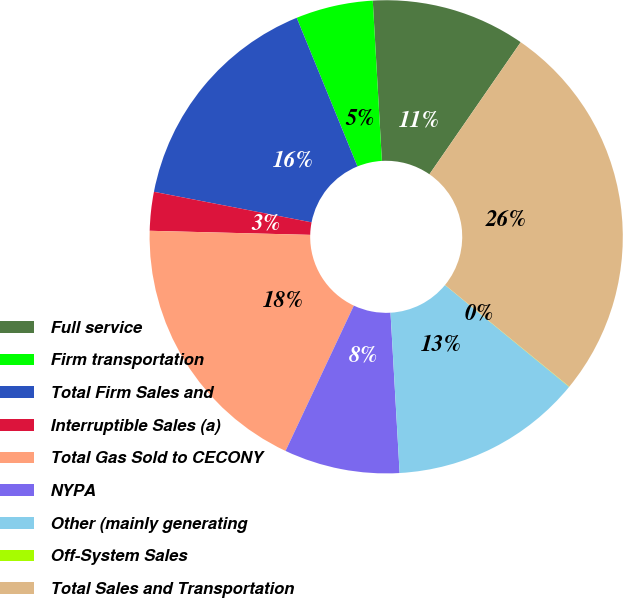Convert chart to OTSL. <chart><loc_0><loc_0><loc_500><loc_500><pie_chart><fcel>Full service<fcel>Firm transportation<fcel>Total Firm Sales and<fcel>Interruptible Sales (a)<fcel>Total Gas Sold to CECONY<fcel>NYPA<fcel>Other (mainly generating<fcel>Off-System Sales<fcel>Total Sales and Transportation<nl><fcel>10.53%<fcel>5.27%<fcel>15.78%<fcel>2.64%<fcel>18.41%<fcel>7.9%<fcel>13.16%<fcel>0.02%<fcel>26.29%<nl></chart> 